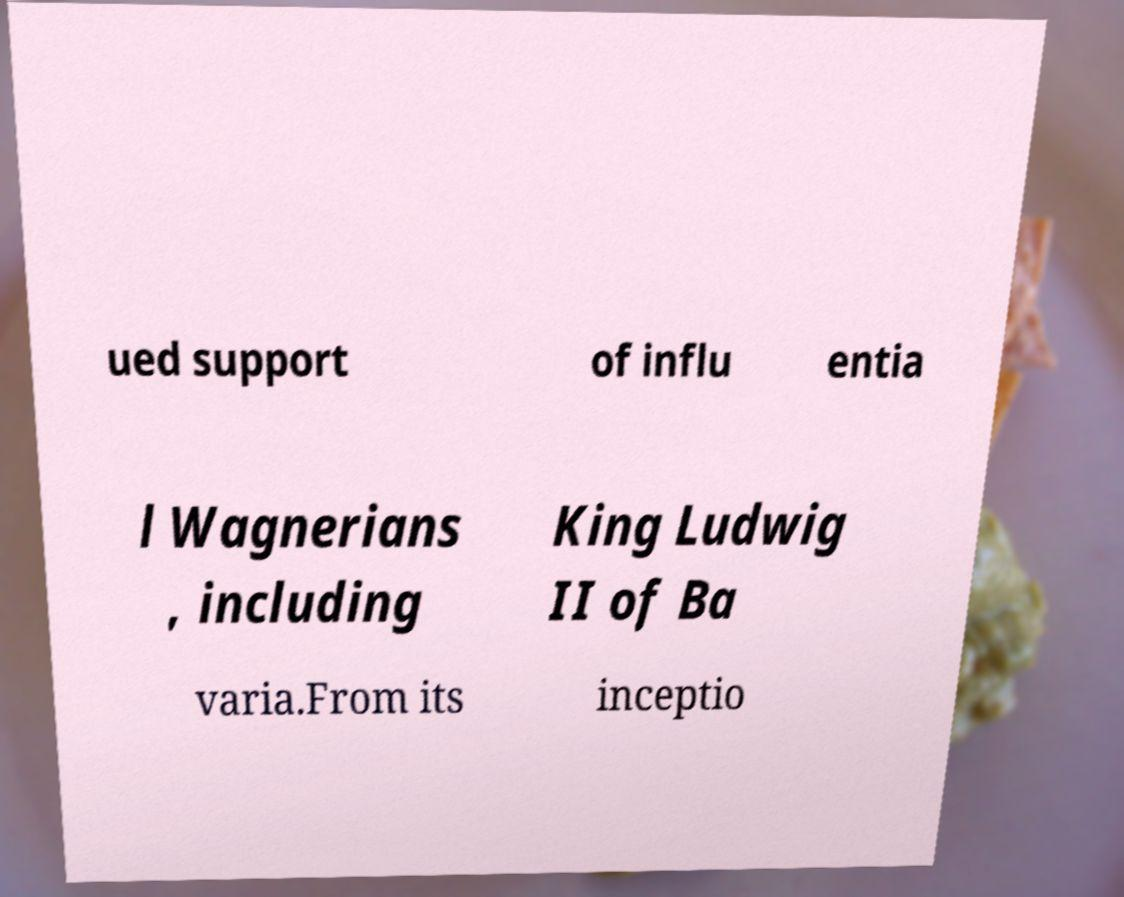Could you extract and type out the text from this image? ued support of influ entia l Wagnerians , including King Ludwig II of Ba varia.From its inceptio 